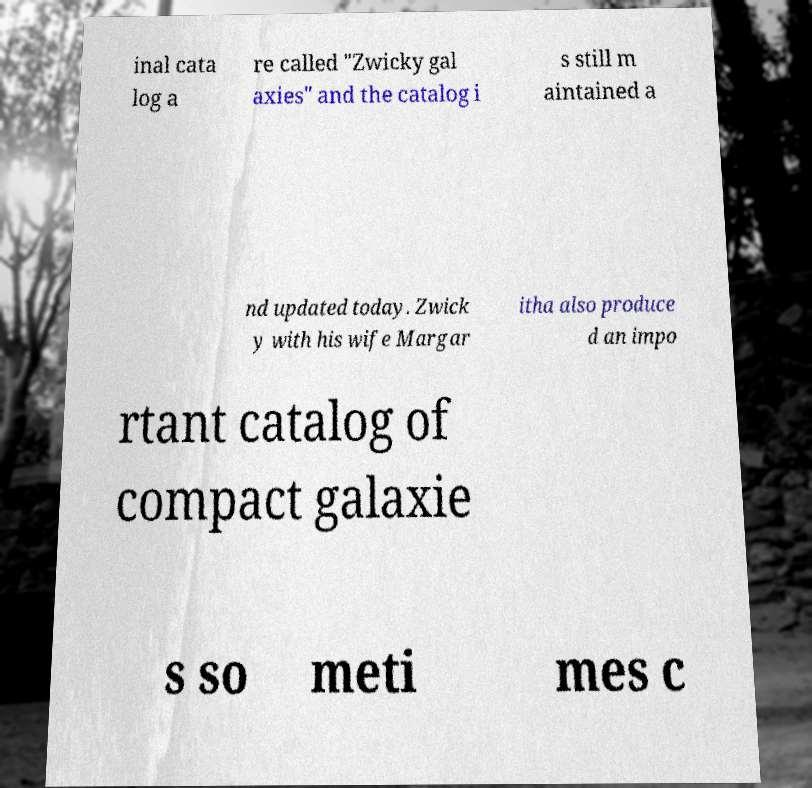For documentation purposes, I need the text within this image transcribed. Could you provide that? inal cata log a re called "Zwicky gal axies" and the catalog i s still m aintained a nd updated today. Zwick y with his wife Margar itha also produce d an impo rtant catalog of compact galaxie s so meti mes c 